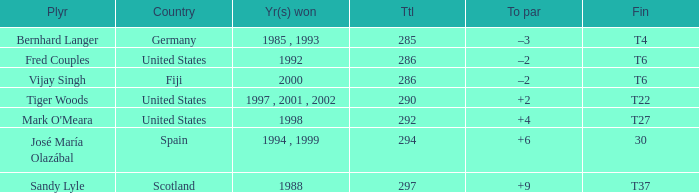Which country has a finish of t22? United States. 